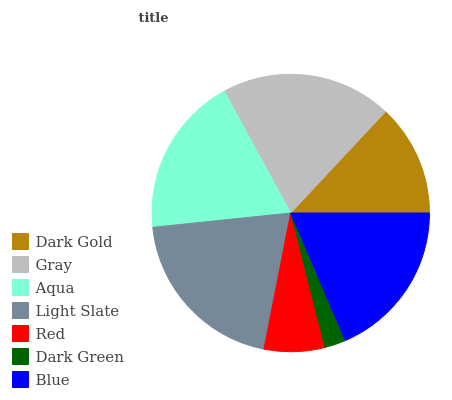Is Dark Green the minimum?
Answer yes or no. Yes. Is Light Slate the maximum?
Answer yes or no. Yes. Is Gray the minimum?
Answer yes or no. No. Is Gray the maximum?
Answer yes or no. No. Is Gray greater than Dark Gold?
Answer yes or no. Yes. Is Dark Gold less than Gray?
Answer yes or no. Yes. Is Dark Gold greater than Gray?
Answer yes or no. No. Is Gray less than Dark Gold?
Answer yes or no. No. Is Blue the high median?
Answer yes or no. Yes. Is Blue the low median?
Answer yes or no. Yes. Is Gray the high median?
Answer yes or no. No. Is Red the low median?
Answer yes or no. No. 